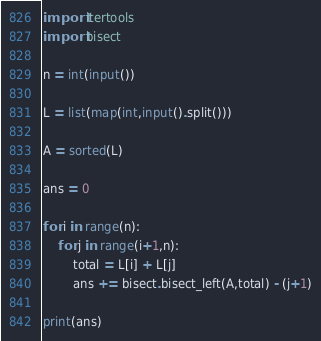Convert code to text. <code><loc_0><loc_0><loc_500><loc_500><_Python_>import itertools
import bisect

n = int(input())

L = list(map(int,input().split()))

A = sorted(L)

ans = 0

for i in range(n):
    for j in range(i+1,n):
        total = L[i] + L[j]
        ans += bisect.bisect_left(A,total) - (j+1)

print(ans)  
</code> 